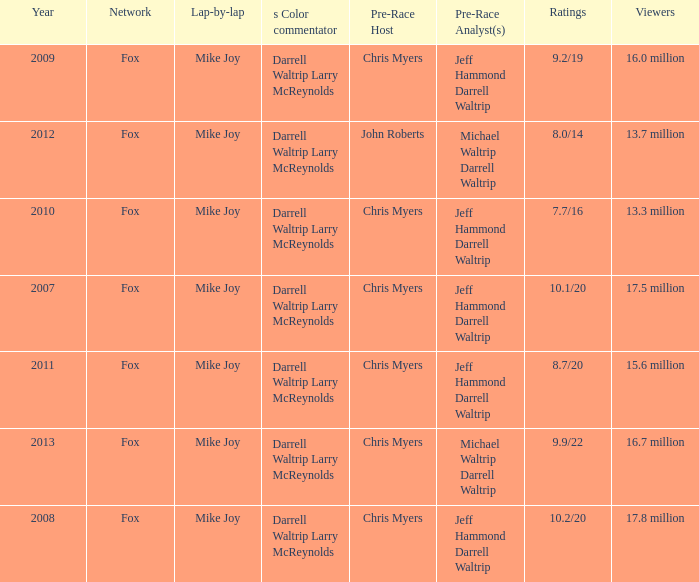Which Network has 17.5 million Viewers? Fox. 